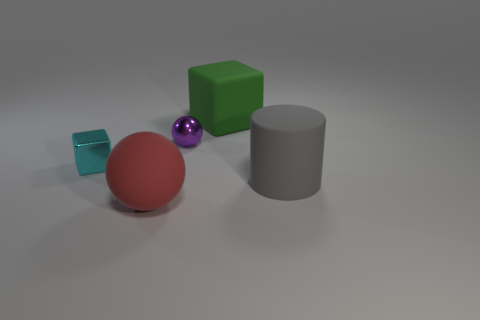Are there any small blocks of the same color as the small sphere?
Give a very brief answer. No. What number of big matte cubes are there?
Your response must be concise. 1. What material is the cube on the left side of the rubber object that is behind the thing that is on the right side of the large green cube?
Your answer should be very brief. Metal. Are there any cyan objects that have the same material as the small purple sphere?
Ensure brevity in your answer.  Yes. Are the big green cube and the small block made of the same material?
Offer a very short reply. No. How many cylinders are either tiny cyan things or red objects?
Your answer should be very brief. 0. The large ball that is made of the same material as the big cylinder is what color?
Ensure brevity in your answer.  Red. Is the number of large things less than the number of metallic things?
Make the answer very short. No. There is a tiny metallic object that is left of the small metallic sphere; does it have the same shape as the thing behind the purple metal object?
Ensure brevity in your answer.  Yes. What number of things are big cyan metal blocks or large matte blocks?
Make the answer very short. 1. 